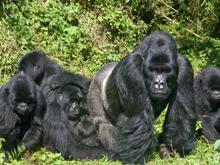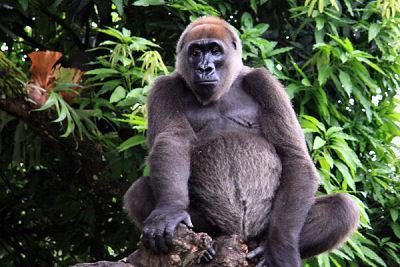The first image is the image on the left, the second image is the image on the right. For the images shown, is this caption "One of the images features an adult gorilla carrying a baby gorilla." true? Answer yes or no. No. The first image is the image on the left, the second image is the image on the right. Evaluate the accuracy of this statement regarding the images: "One of the images contain only one gorrilla.". Is it true? Answer yes or no. Yes. 